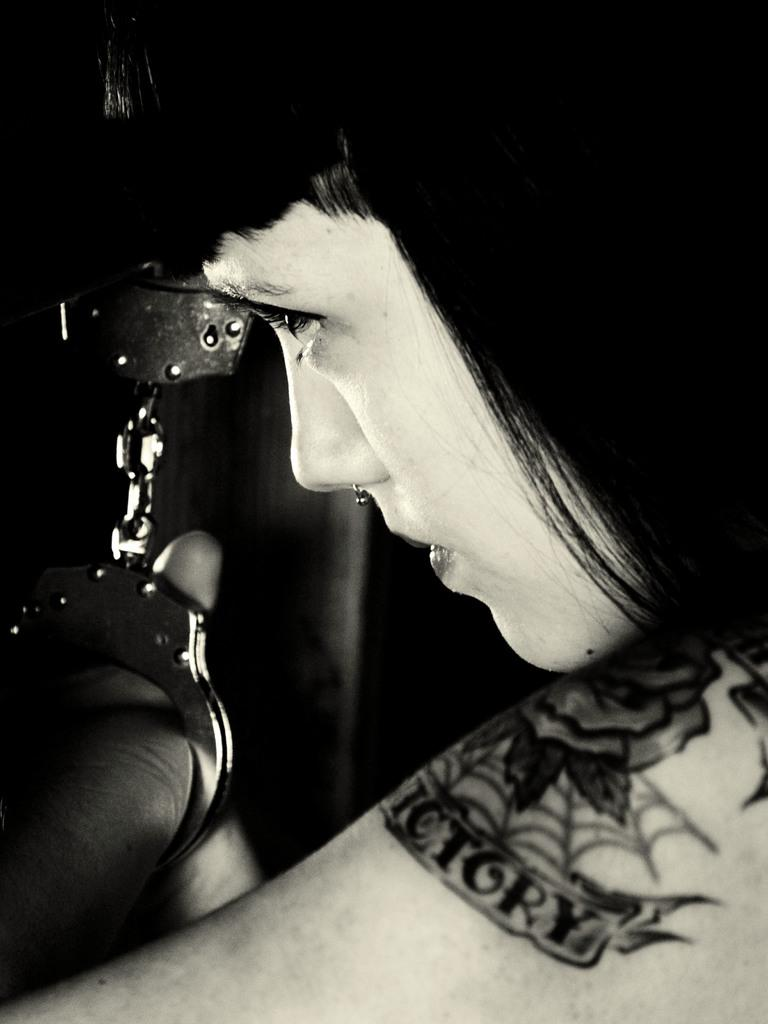Who is the main subject in the image? There is a woman in the middle of the image. What can be observed about the background of the image? The background of the image is dark. How would you describe the color scheme of the image? The image is black and white. What type of poisonous apple can be seen in the woman's hand in the image? There is no apple, poisonous or otherwise, present in the image. Is there a garden visible in the background of the image? The background of the image is dark, and there is no indication of a garden. 